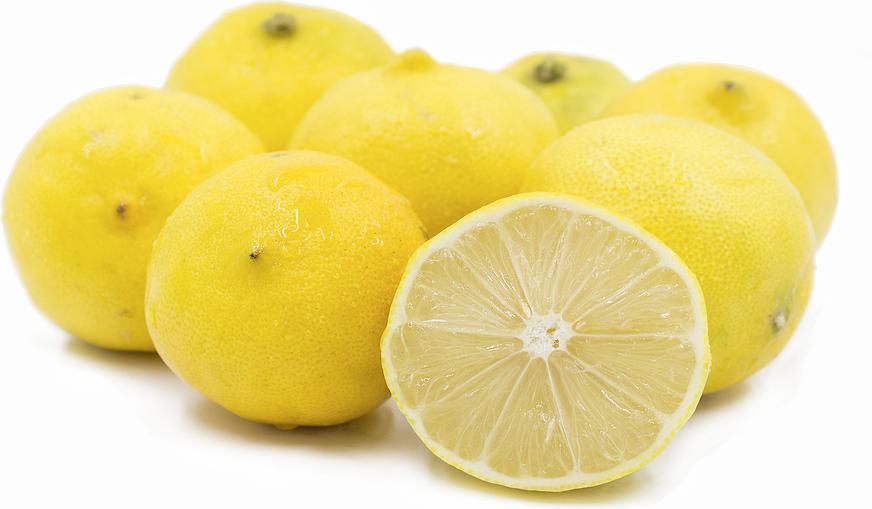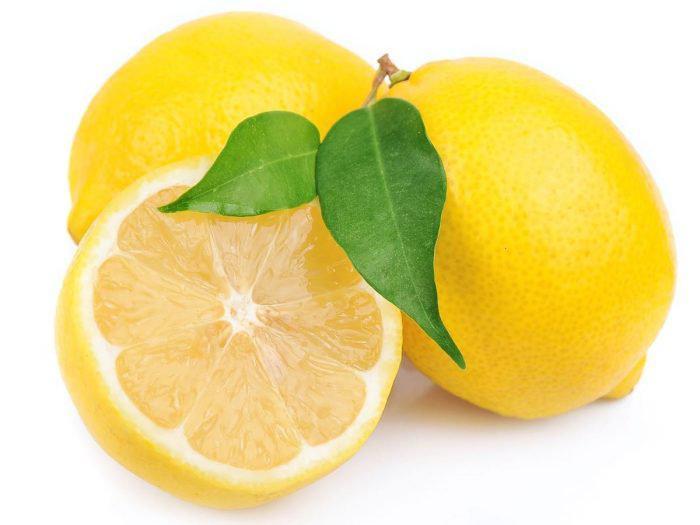The first image is the image on the left, the second image is the image on the right. Evaluate the accuracy of this statement regarding the images: "The right image contains three lemons, one of which has been cut in half.". Is it true? Answer yes or no. Yes. The first image is the image on the left, the second image is the image on the right. For the images shown, is this caption "In at least one image there are at least four different types of citrus fruit." true? Answer yes or no. No. 